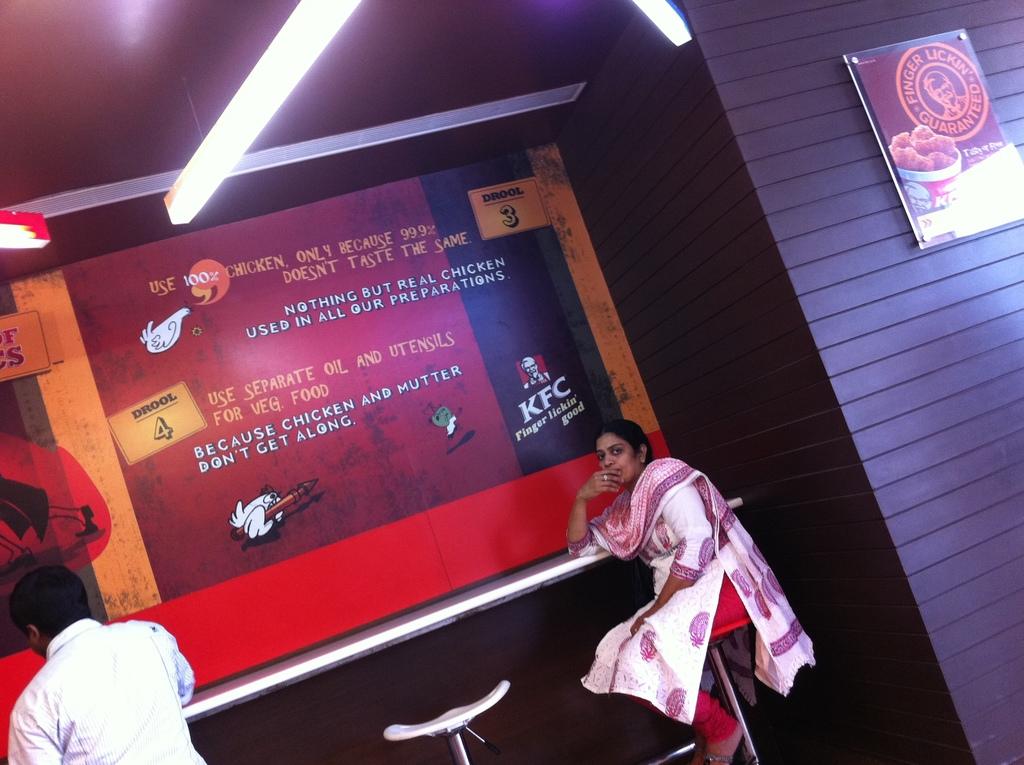What meat does the restaurant say they use at the top?
Make the answer very short. Chicken. What is the brand shown in the bottom right?
Give a very brief answer. Kfc. 